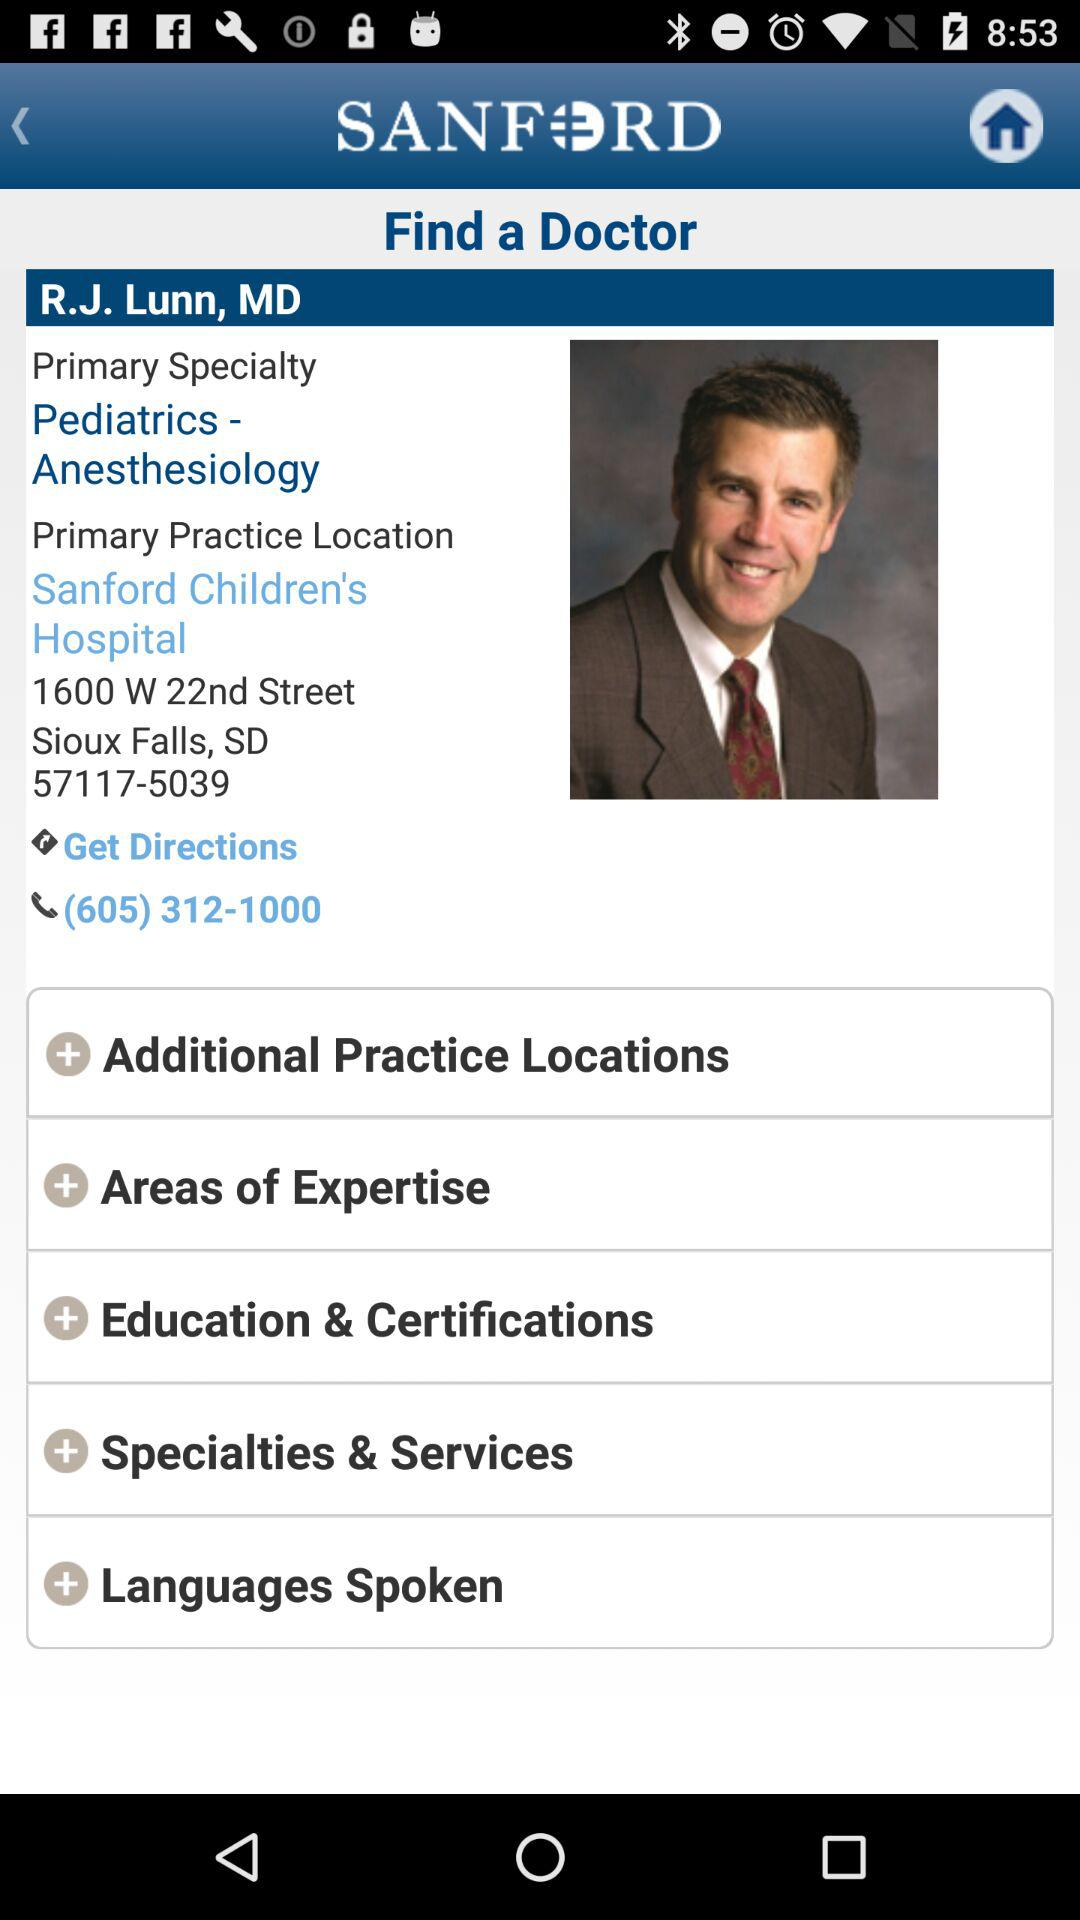What is the primary practice location? The primary practice location is "Sanford Children's Hospital". 